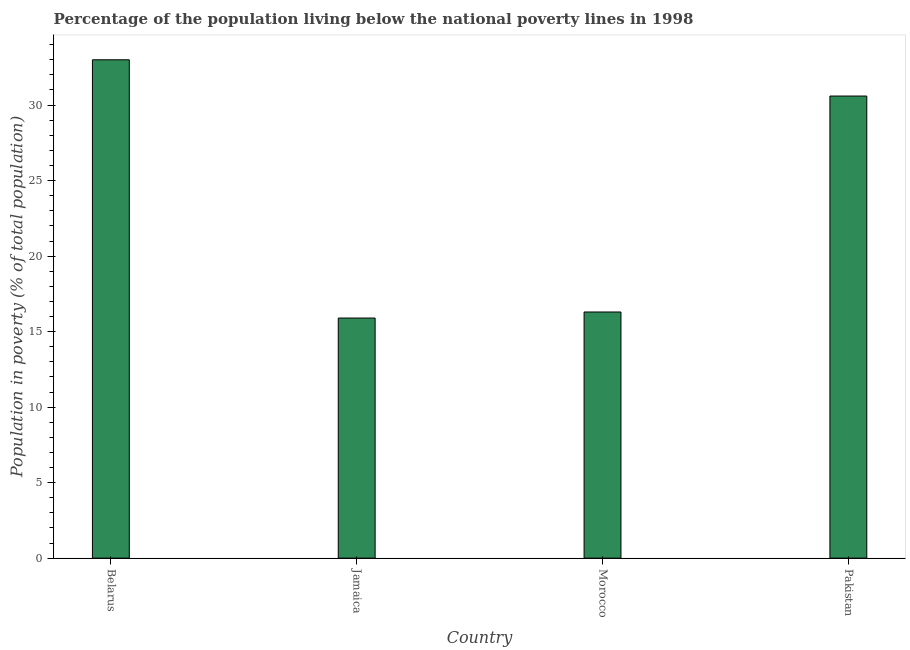Does the graph contain any zero values?
Ensure brevity in your answer.  No. Does the graph contain grids?
Offer a terse response. No. What is the title of the graph?
Your response must be concise. Percentage of the population living below the national poverty lines in 1998. What is the label or title of the X-axis?
Make the answer very short. Country. What is the label or title of the Y-axis?
Offer a very short reply. Population in poverty (% of total population). Across all countries, what is the minimum percentage of population living below poverty line?
Offer a very short reply. 15.9. In which country was the percentage of population living below poverty line maximum?
Give a very brief answer. Belarus. In which country was the percentage of population living below poverty line minimum?
Your answer should be very brief. Jamaica. What is the sum of the percentage of population living below poverty line?
Your response must be concise. 95.8. What is the difference between the percentage of population living below poverty line in Jamaica and Morocco?
Provide a short and direct response. -0.4. What is the average percentage of population living below poverty line per country?
Your answer should be very brief. 23.95. What is the median percentage of population living below poverty line?
Offer a very short reply. 23.45. What is the ratio of the percentage of population living below poverty line in Jamaica to that in Morocco?
Provide a succinct answer. 0.97. Is the difference between the percentage of population living below poverty line in Jamaica and Pakistan greater than the difference between any two countries?
Your answer should be compact. No. What is the difference between the highest and the second highest percentage of population living below poverty line?
Your answer should be compact. 2.4. Is the sum of the percentage of population living below poverty line in Belarus and Morocco greater than the maximum percentage of population living below poverty line across all countries?
Give a very brief answer. Yes. What is the difference between the highest and the lowest percentage of population living below poverty line?
Your answer should be compact. 17.1. In how many countries, is the percentage of population living below poverty line greater than the average percentage of population living below poverty line taken over all countries?
Offer a terse response. 2. How many bars are there?
Offer a very short reply. 4. How many countries are there in the graph?
Provide a succinct answer. 4. Are the values on the major ticks of Y-axis written in scientific E-notation?
Offer a terse response. No. What is the Population in poverty (% of total population) in Jamaica?
Provide a short and direct response. 15.9. What is the Population in poverty (% of total population) in Morocco?
Offer a terse response. 16.3. What is the Population in poverty (% of total population) of Pakistan?
Your answer should be compact. 30.6. What is the difference between the Population in poverty (% of total population) in Belarus and Jamaica?
Keep it short and to the point. 17.1. What is the difference between the Population in poverty (% of total population) in Belarus and Morocco?
Your response must be concise. 16.7. What is the difference between the Population in poverty (% of total population) in Belarus and Pakistan?
Offer a terse response. 2.4. What is the difference between the Population in poverty (% of total population) in Jamaica and Pakistan?
Keep it short and to the point. -14.7. What is the difference between the Population in poverty (% of total population) in Morocco and Pakistan?
Ensure brevity in your answer.  -14.3. What is the ratio of the Population in poverty (% of total population) in Belarus to that in Jamaica?
Offer a terse response. 2.08. What is the ratio of the Population in poverty (% of total population) in Belarus to that in Morocco?
Ensure brevity in your answer.  2.02. What is the ratio of the Population in poverty (% of total population) in Belarus to that in Pakistan?
Your answer should be compact. 1.08. What is the ratio of the Population in poverty (% of total population) in Jamaica to that in Morocco?
Ensure brevity in your answer.  0.97. What is the ratio of the Population in poverty (% of total population) in Jamaica to that in Pakistan?
Your answer should be compact. 0.52. What is the ratio of the Population in poverty (% of total population) in Morocco to that in Pakistan?
Offer a very short reply. 0.53. 